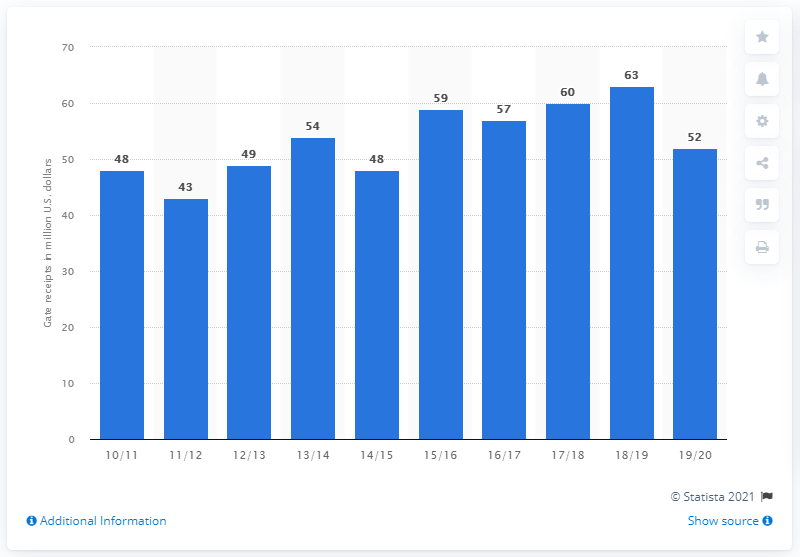Indicate a few pertinent items in this graphic. In the 2019/20 season, the Oklahoma City Thunder generated gate receipts of approximately $52 million in revenue from ticket sales. 